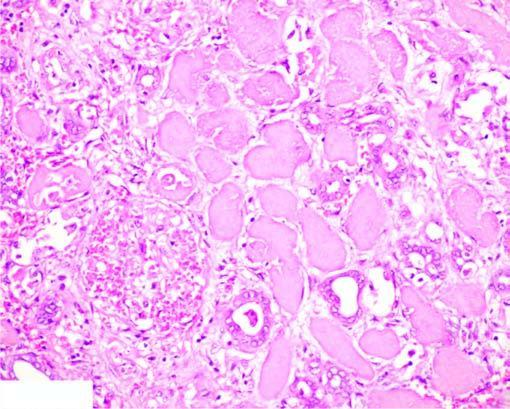re the outline of tubules still maintained?
Answer the question using a single word or phrase. Yes 